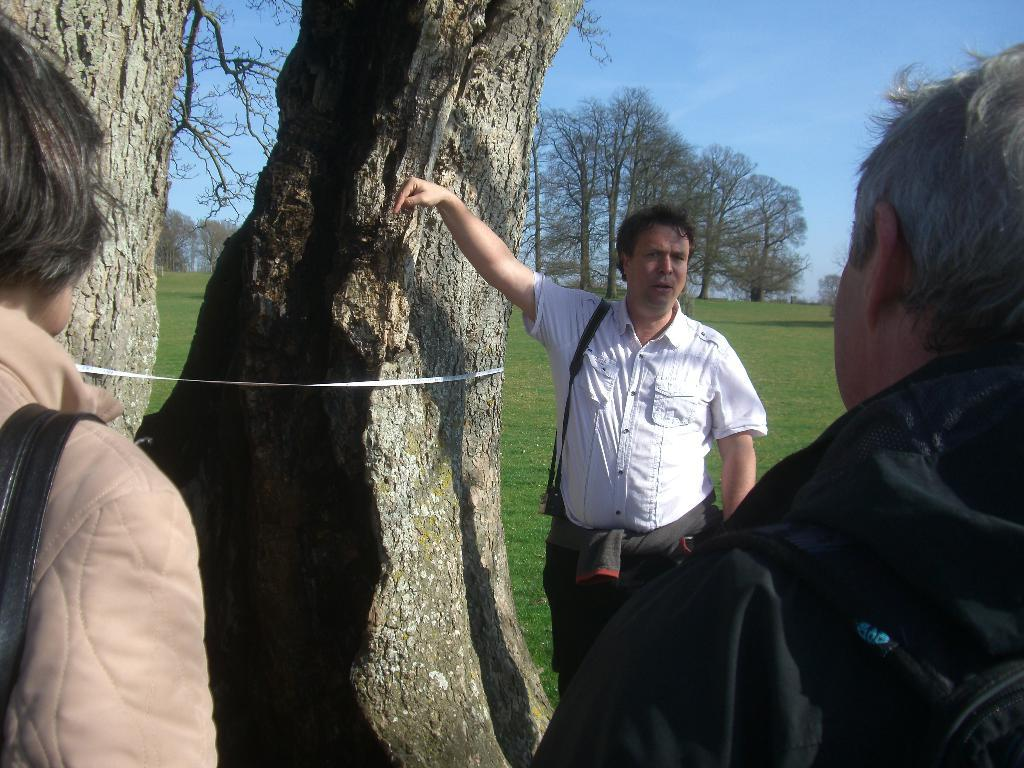How many people are present in the image? There are three people on the ground in the image. What object can be seen in the image that is used for measuring? There is a measuring tape visible in the image. What type of natural environment is visible in the background of the image? There are trees in the background of the image. What part of the natural environment is visible in the background of the image? The sky is visible in the background of the image. What type of waste can be seen being disposed of in the image? There is no waste present in the image; it only features three people on the ground, a measuring tape, trees, and the sky. 